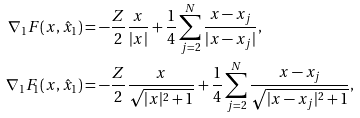Convert formula to latex. <formula><loc_0><loc_0><loc_500><loc_500>\nabla _ { 1 } F ( x , \hat { x } _ { 1 } ) & = - \frac { Z } { 2 } \frac { x } { | x | } + \frac { 1 } { 4 } \sum _ { j = 2 } ^ { N } \frac { x - x _ { j } } { | x - x _ { j } | } , \\ \nabla _ { 1 } F _ { 1 } ( x , \hat { x } _ { 1 } ) & = - \frac { Z } { 2 } \frac { x } { \sqrt { | x | ^ { 2 } + 1 } } + \frac { 1 } { 4 } \sum _ { j = 2 } ^ { N } \frac { x - x _ { j } } { \sqrt { | x - x _ { j } | ^ { 2 } + 1 } } ,</formula> 